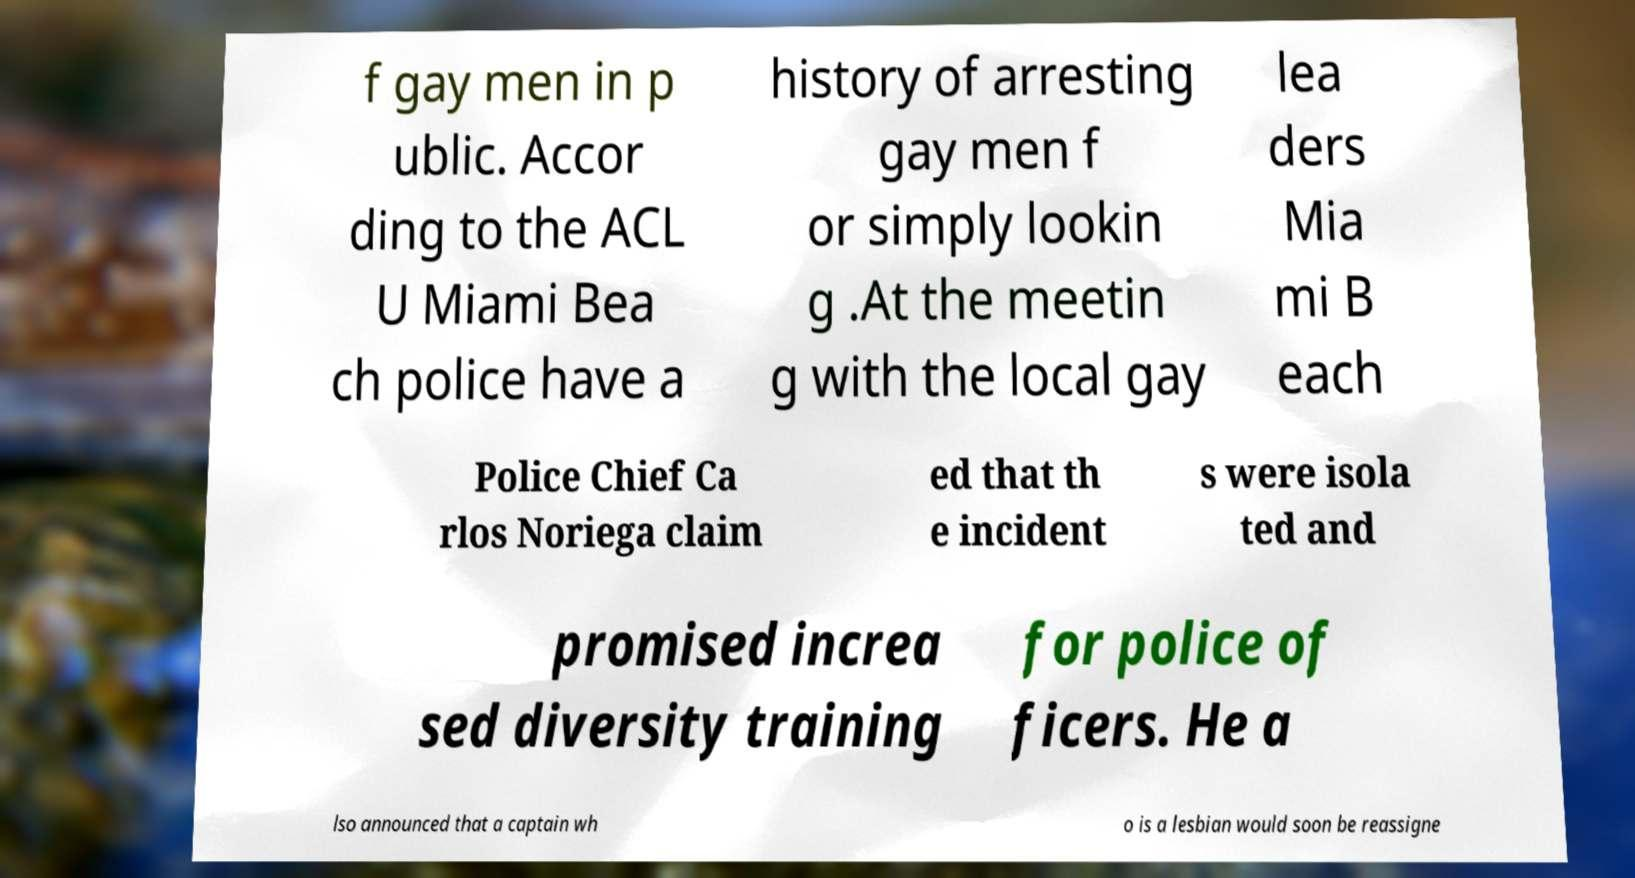There's text embedded in this image that I need extracted. Can you transcribe it verbatim? f gay men in p ublic. Accor ding to the ACL U Miami Bea ch police have a history of arresting gay men f or simply lookin g .At the meetin g with the local gay lea ders Mia mi B each Police Chief Ca rlos Noriega claim ed that th e incident s were isola ted and promised increa sed diversity training for police of ficers. He a lso announced that a captain wh o is a lesbian would soon be reassigne 